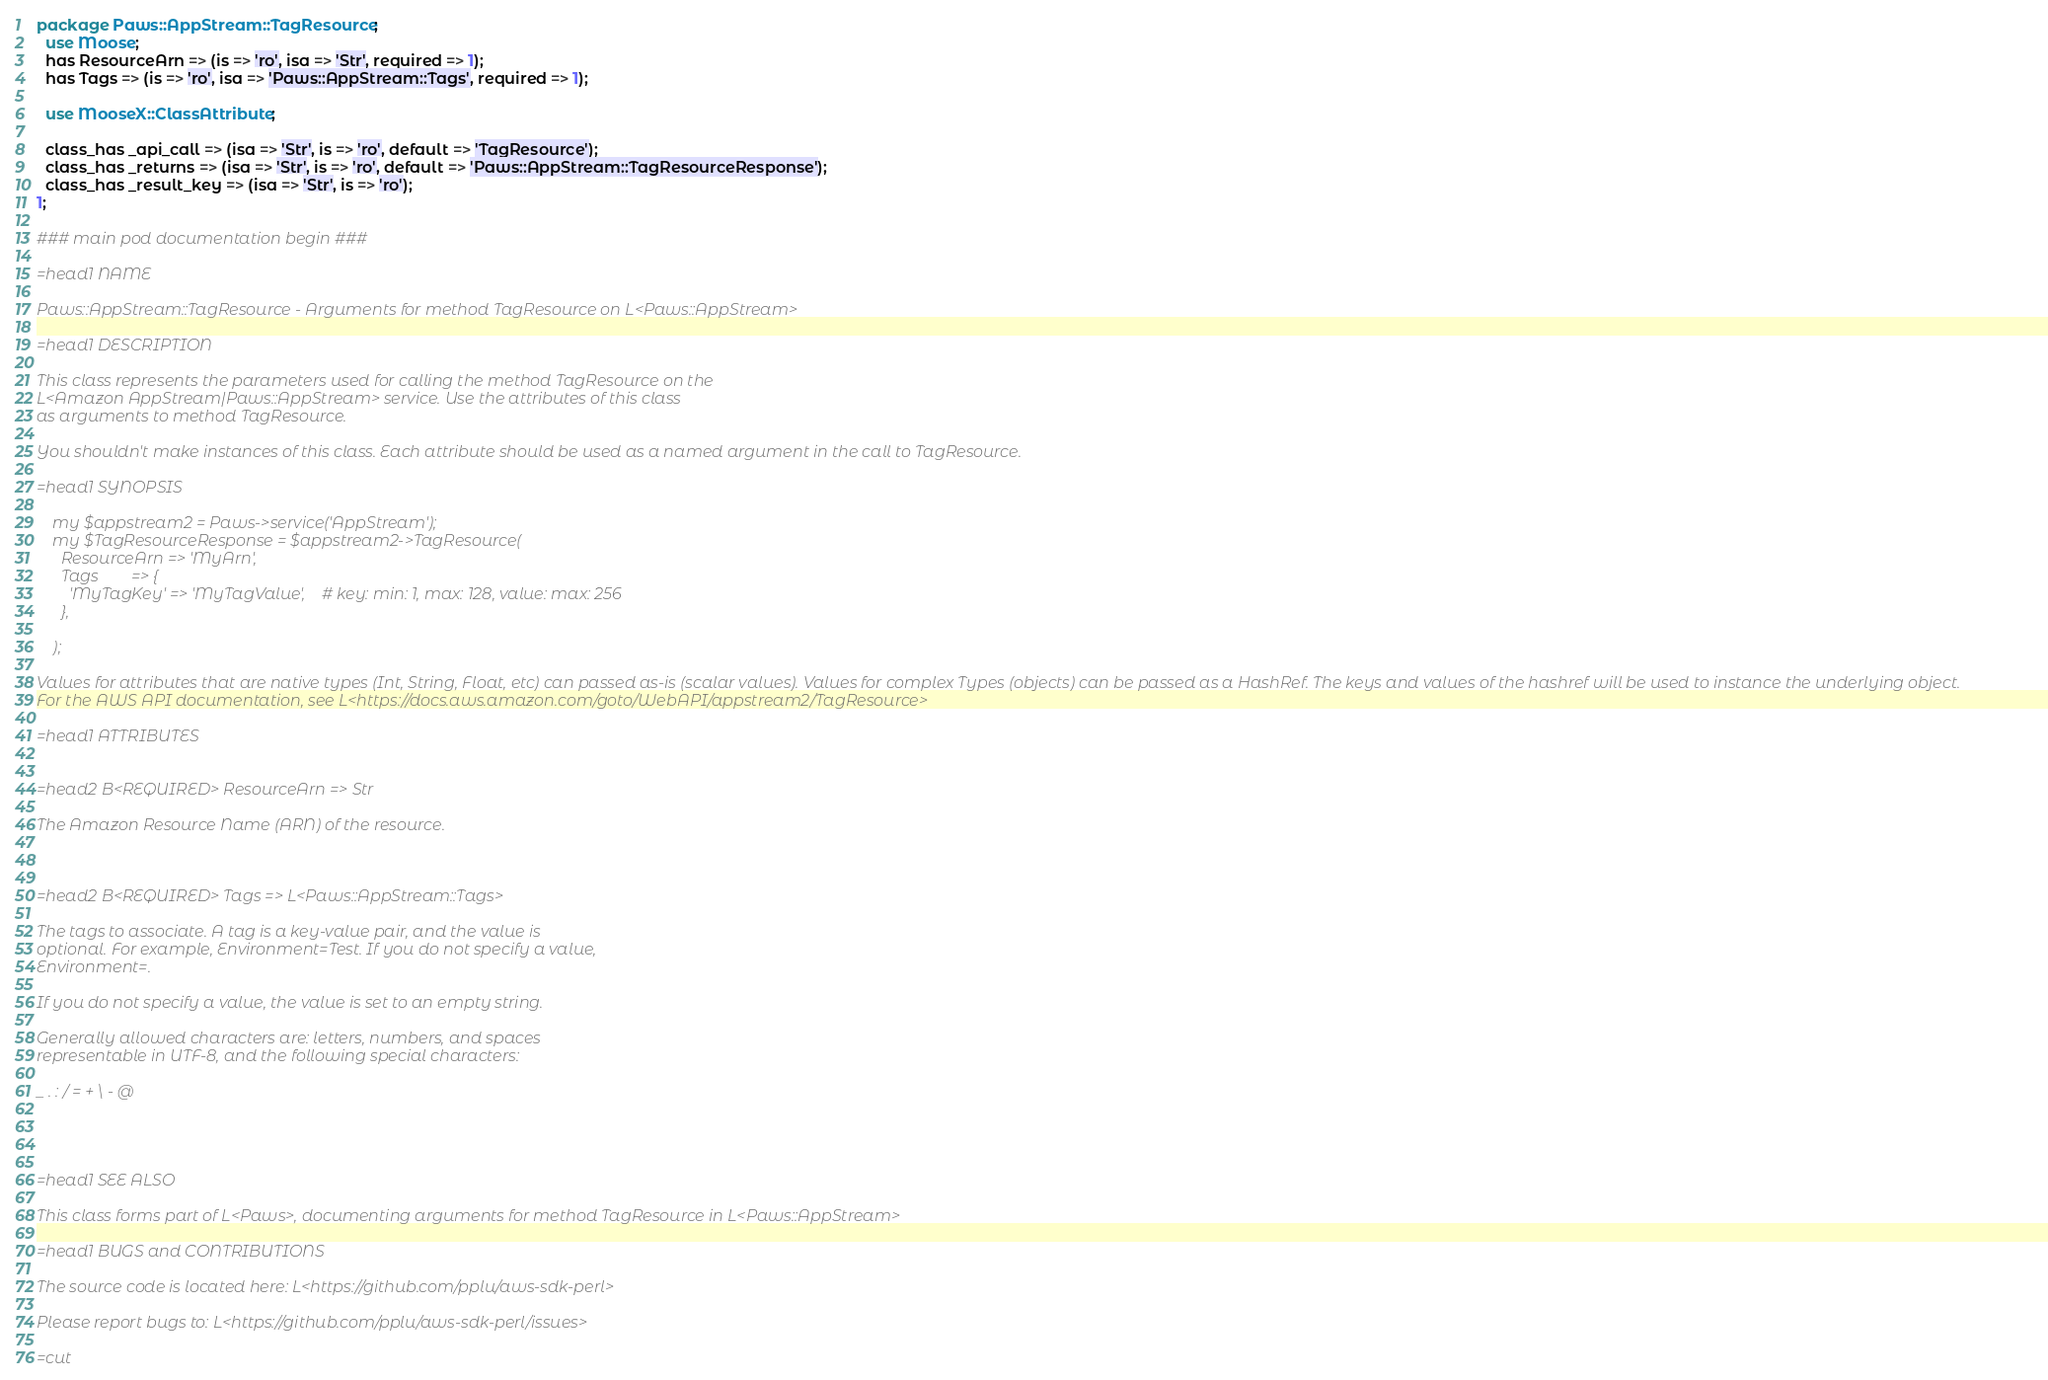<code> <loc_0><loc_0><loc_500><loc_500><_Perl_>
package Paws::AppStream::TagResource;
  use Moose;
  has ResourceArn => (is => 'ro', isa => 'Str', required => 1);
  has Tags => (is => 'ro', isa => 'Paws::AppStream::Tags', required => 1);

  use MooseX::ClassAttribute;

  class_has _api_call => (isa => 'Str', is => 'ro', default => 'TagResource');
  class_has _returns => (isa => 'Str', is => 'ro', default => 'Paws::AppStream::TagResourceResponse');
  class_has _result_key => (isa => 'Str', is => 'ro');
1;

### main pod documentation begin ###

=head1 NAME

Paws::AppStream::TagResource - Arguments for method TagResource on L<Paws::AppStream>

=head1 DESCRIPTION

This class represents the parameters used for calling the method TagResource on the
L<Amazon AppStream|Paws::AppStream> service. Use the attributes of this class
as arguments to method TagResource.

You shouldn't make instances of this class. Each attribute should be used as a named argument in the call to TagResource.

=head1 SYNOPSIS

    my $appstream2 = Paws->service('AppStream');
    my $TagResourceResponse = $appstream2->TagResource(
      ResourceArn => 'MyArn',
      Tags        => {
        'MyTagKey' => 'MyTagValue',    # key: min: 1, max: 128, value: max: 256
      },

    );

Values for attributes that are native types (Int, String, Float, etc) can passed as-is (scalar values). Values for complex Types (objects) can be passed as a HashRef. The keys and values of the hashref will be used to instance the underlying object.
For the AWS API documentation, see L<https://docs.aws.amazon.com/goto/WebAPI/appstream2/TagResource>

=head1 ATTRIBUTES


=head2 B<REQUIRED> ResourceArn => Str

The Amazon Resource Name (ARN) of the resource.



=head2 B<REQUIRED> Tags => L<Paws::AppStream::Tags>

The tags to associate. A tag is a key-value pair, and the value is
optional. For example, Environment=Test. If you do not specify a value,
Environment=.

If you do not specify a value, the value is set to an empty string.

Generally allowed characters are: letters, numbers, and spaces
representable in UTF-8, and the following special characters:

_ . : / = + \ - @




=head1 SEE ALSO

This class forms part of L<Paws>, documenting arguments for method TagResource in L<Paws::AppStream>

=head1 BUGS and CONTRIBUTIONS

The source code is located here: L<https://github.com/pplu/aws-sdk-perl>

Please report bugs to: L<https://github.com/pplu/aws-sdk-perl/issues>

=cut

</code> 